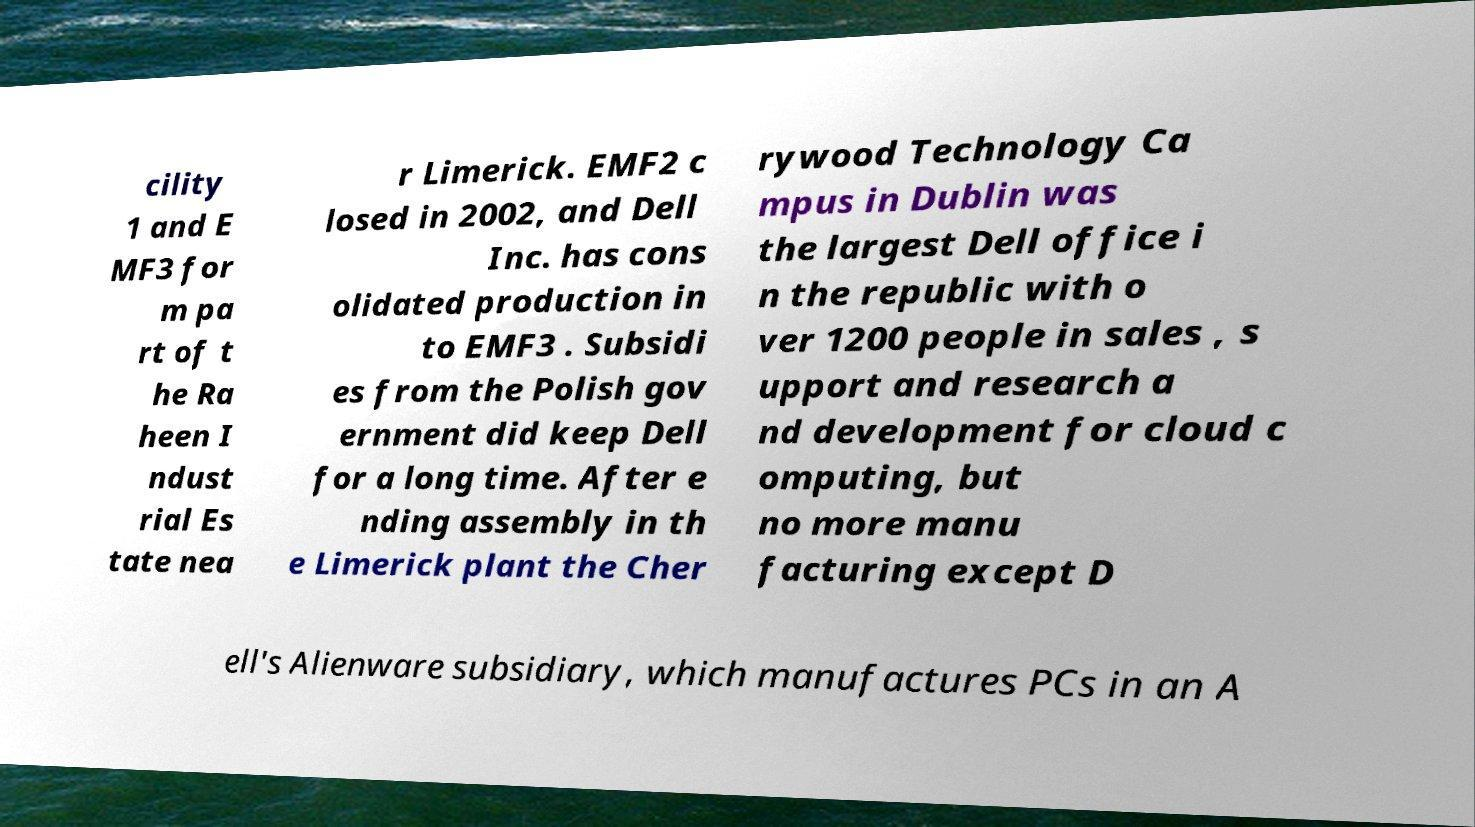Please read and relay the text visible in this image. What does it say? cility 1 and E MF3 for m pa rt of t he Ra heen I ndust rial Es tate nea r Limerick. EMF2 c losed in 2002, and Dell Inc. has cons olidated production in to EMF3 . Subsidi es from the Polish gov ernment did keep Dell for a long time. After e nding assembly in th e Limerick plant the Cher rywood Technology Ca mpus in Dublin was the largest Dell office i n the republic with o ver 1200 people in sales , s upport and research a nd development for cloud c omputing, but no more manu facturing except D ell's Alienware subsidiary, which manufactures PCs in an A 